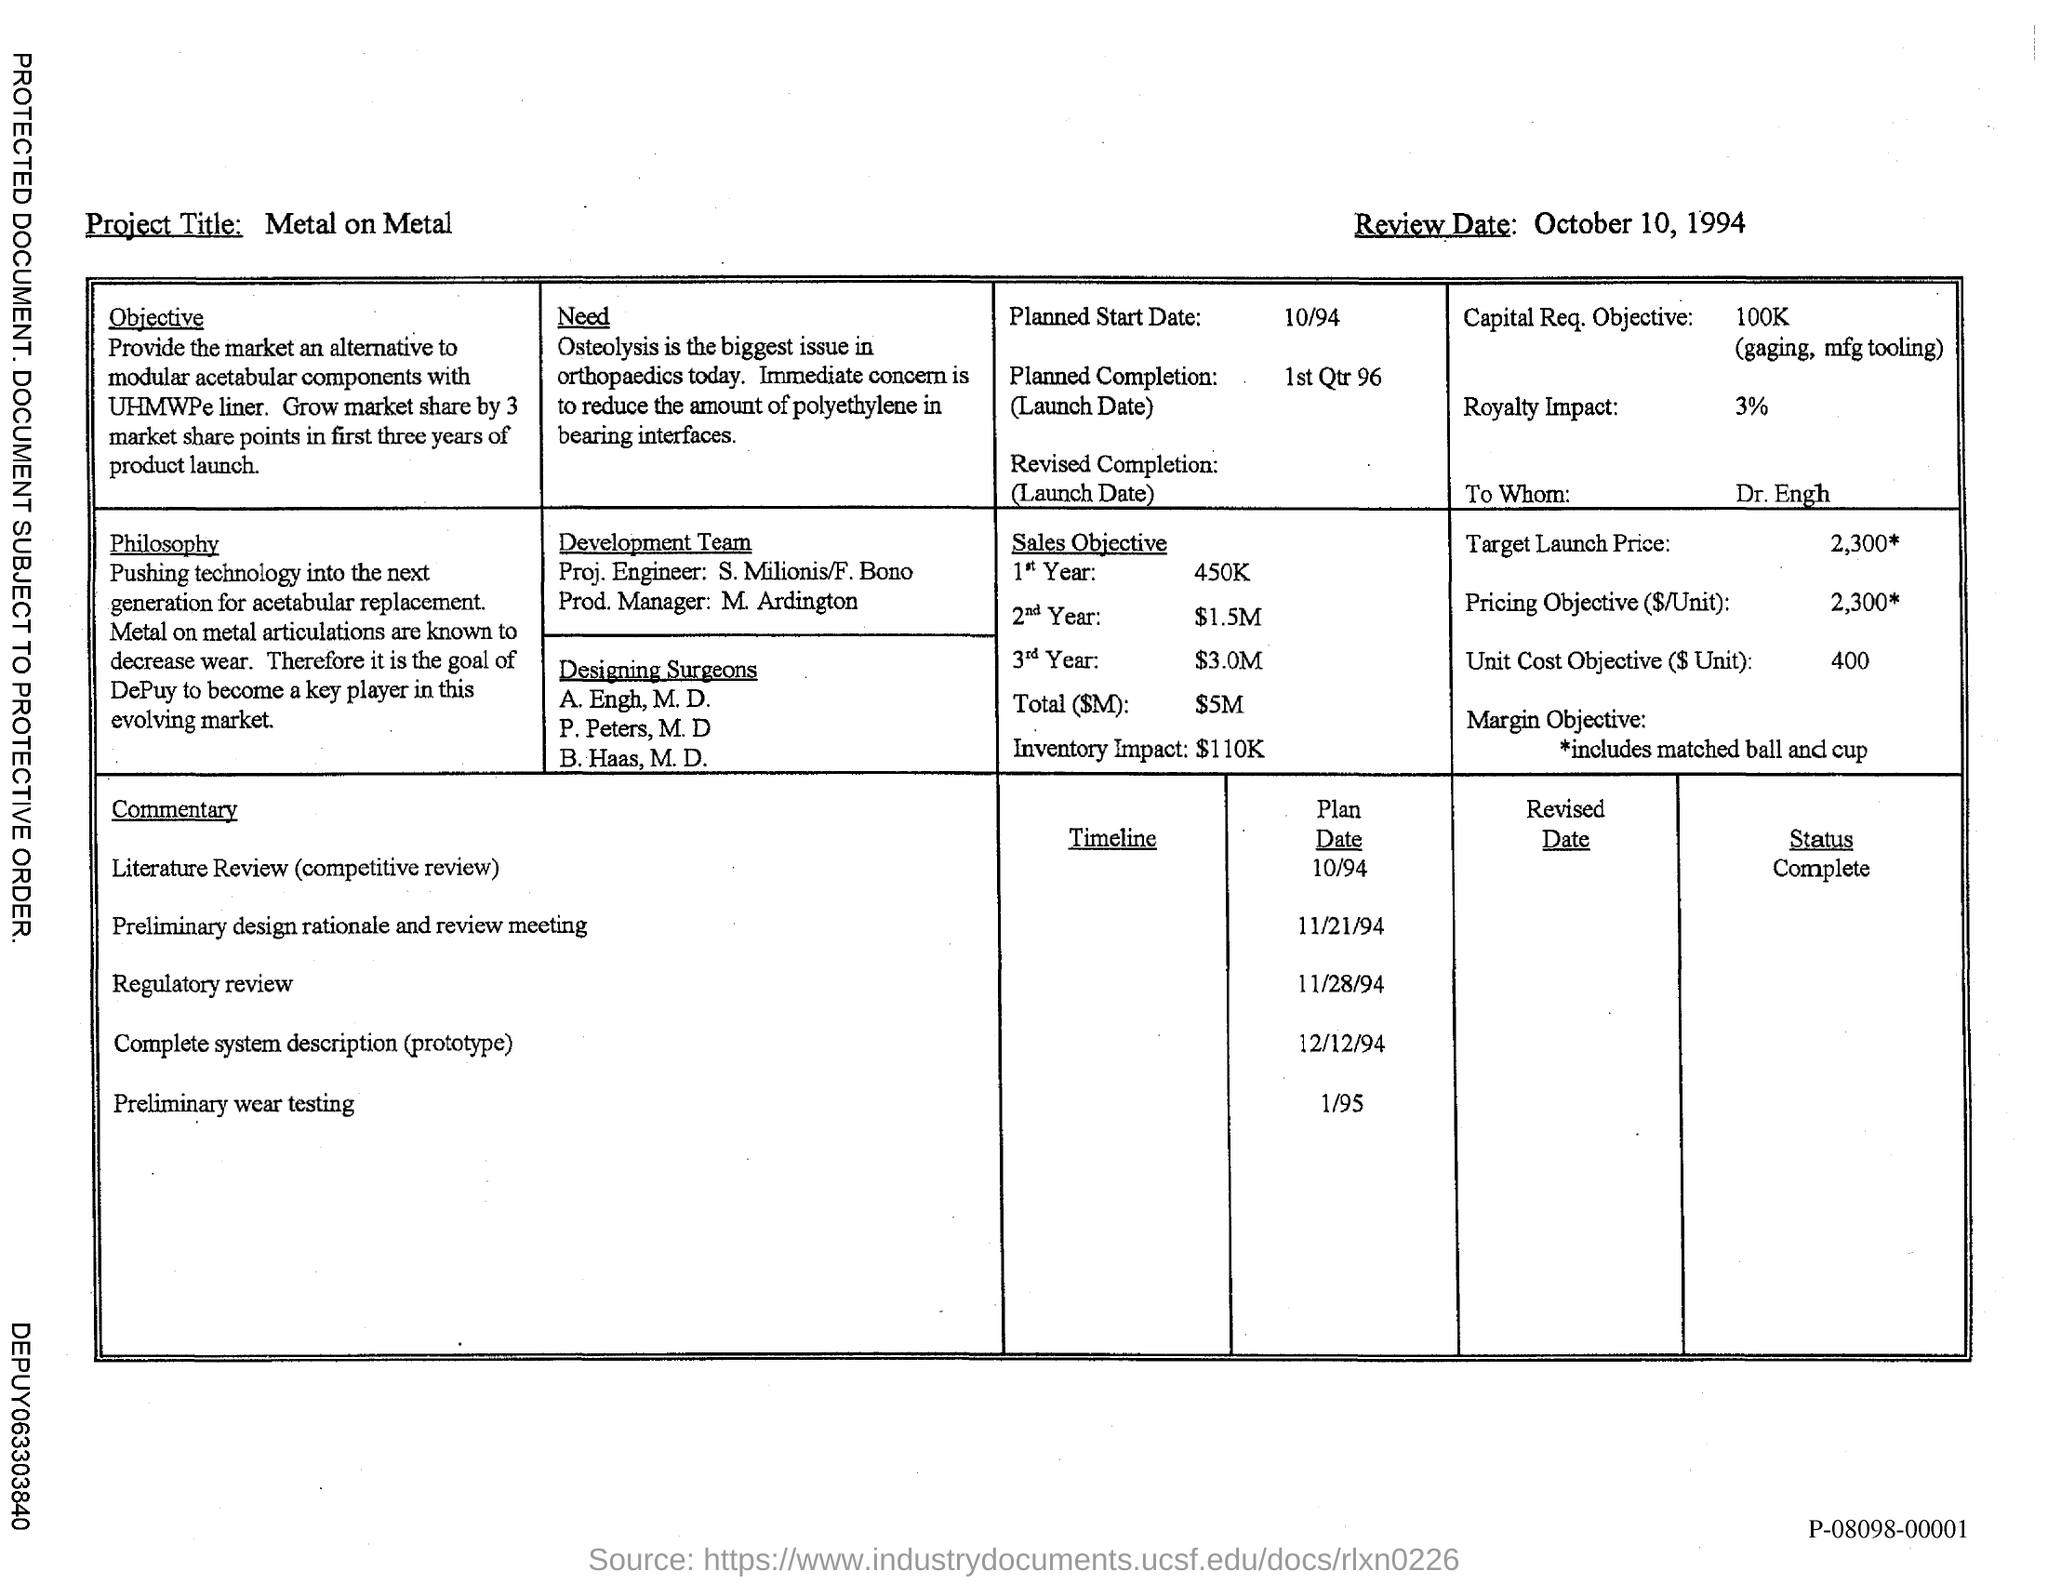Draw attention to some important aspects in this diagram. The review date mentioned in this document is October 10, 1994. The project title mentioned in this document is 'Metal on Metal.' 